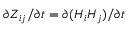<formula> <loc_0><loc_0><loc_500><loc_500>\partial Z _ { i j } / \partial t = \partial ( H _ { i } H _ { j } ) / \partial t</formula> 